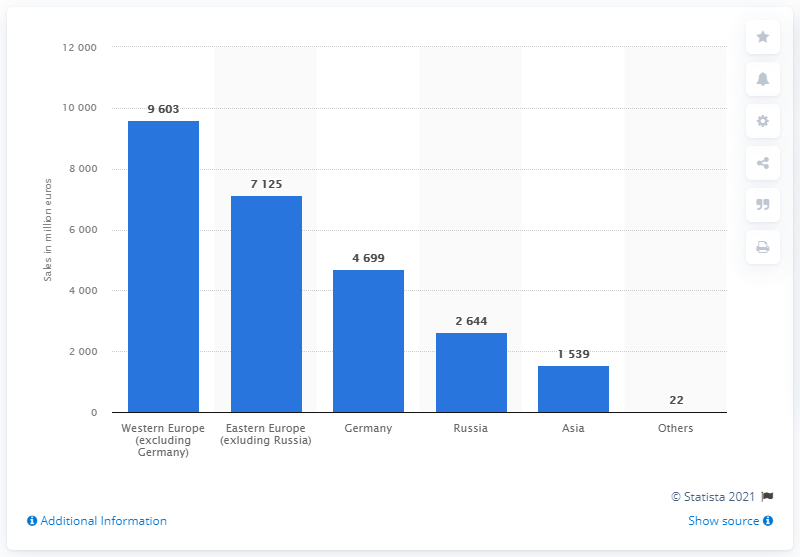Draw attention to some important aspects in this diagram. In the fiscal year 2019/2020, the sales of Metro Group in Western Europe reached a total of 9,603. The total sales of Metro Group in Germany in 2019/2020 were 4,699. 